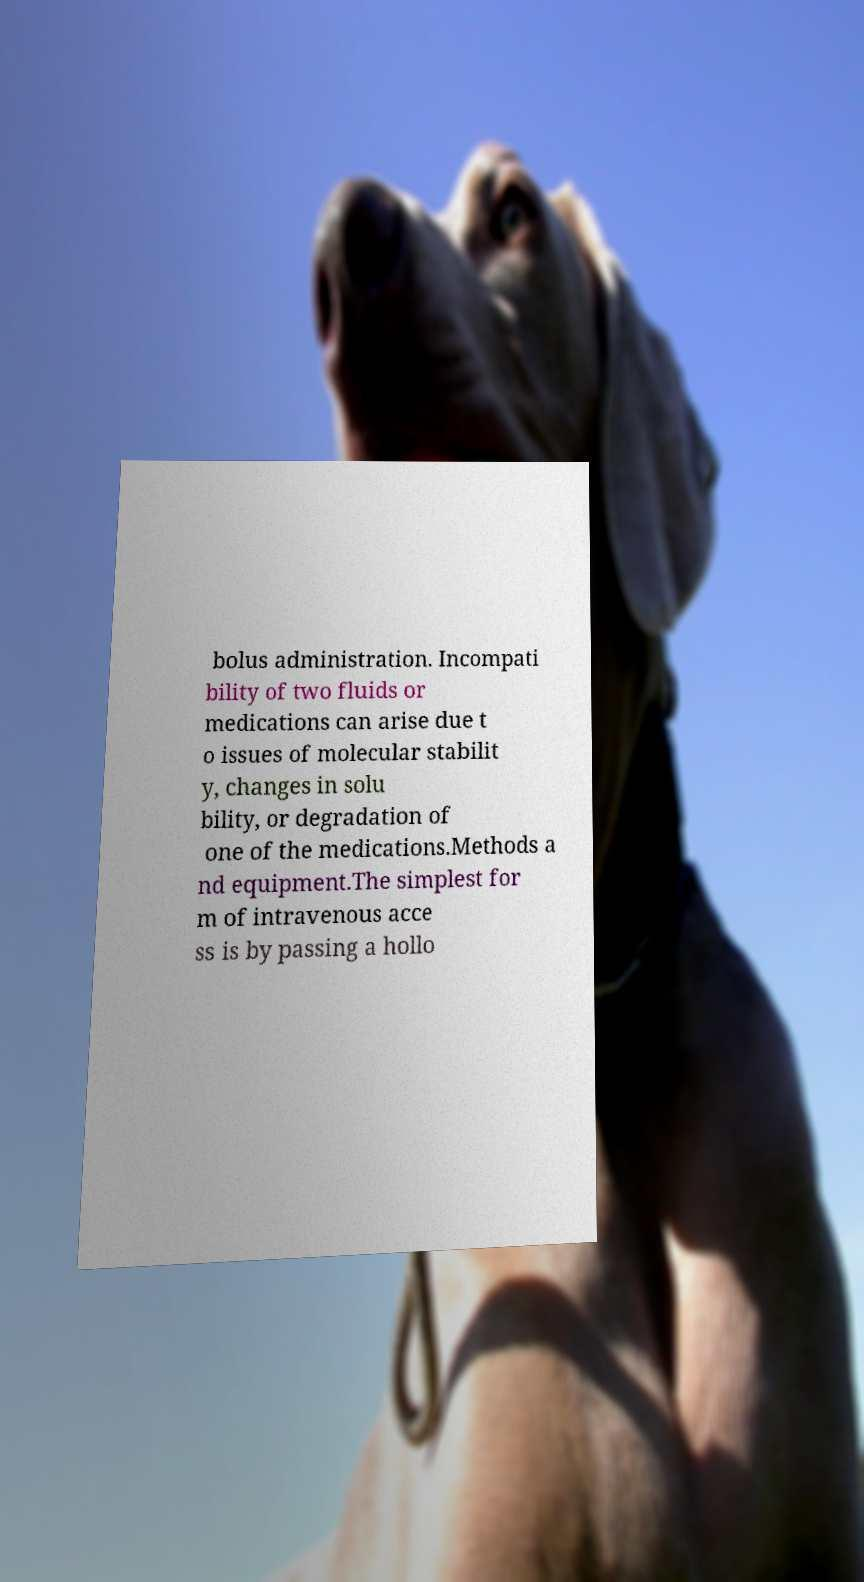Can you read and provide the text displayed in the image?This photo seems to have some interesting text. Can you extract and type it out for me? bolus administration. Incompati bility of two fluids or medications can arise due t o issues of molecular stabilit y, changes in solu bility, or degradation of one of the medications.Methods a nd equipment.The simplest for m of intravenous acce ss is by passing a hollo 